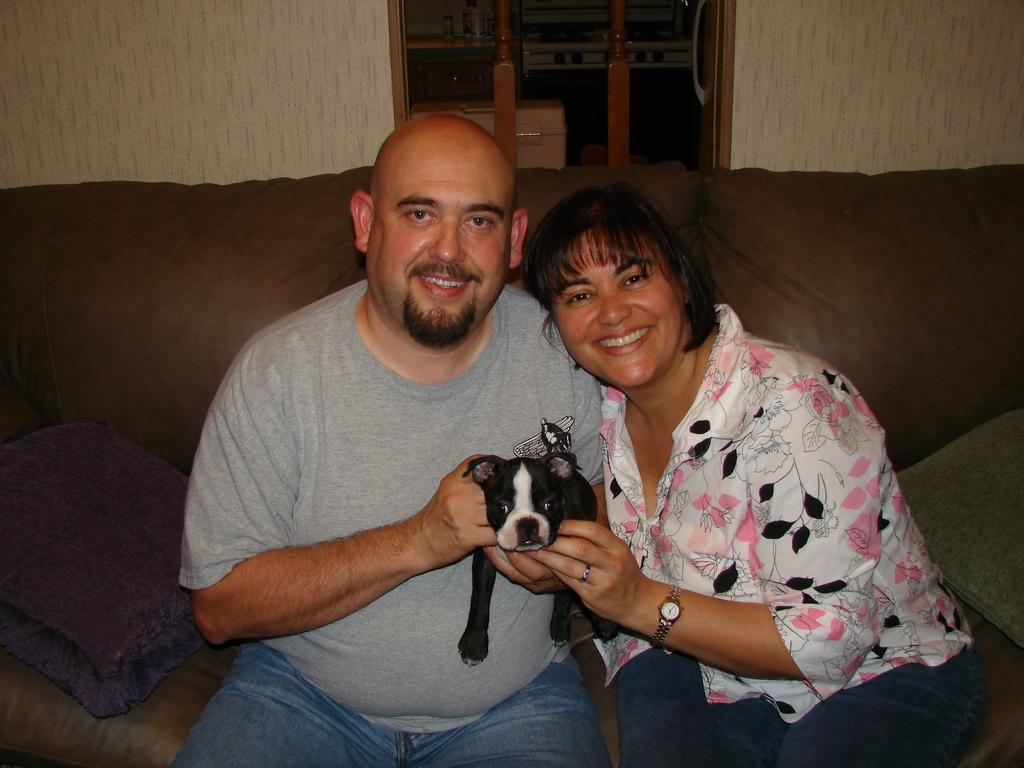What type of flooring is visible in the image? There are white color tiles in the image. What architectural feature can be seen in the image? There is a window in the image. What type of furniture is present in the image? There are two people sitting on a brown color sofa. What is the people holding in the image? The people are holding a black color dog. What type of screw can be seen on the window in the image? There are no screws visible on the window in the image. What type of soap is being used by the people in the image? There is no soap present in the image. 